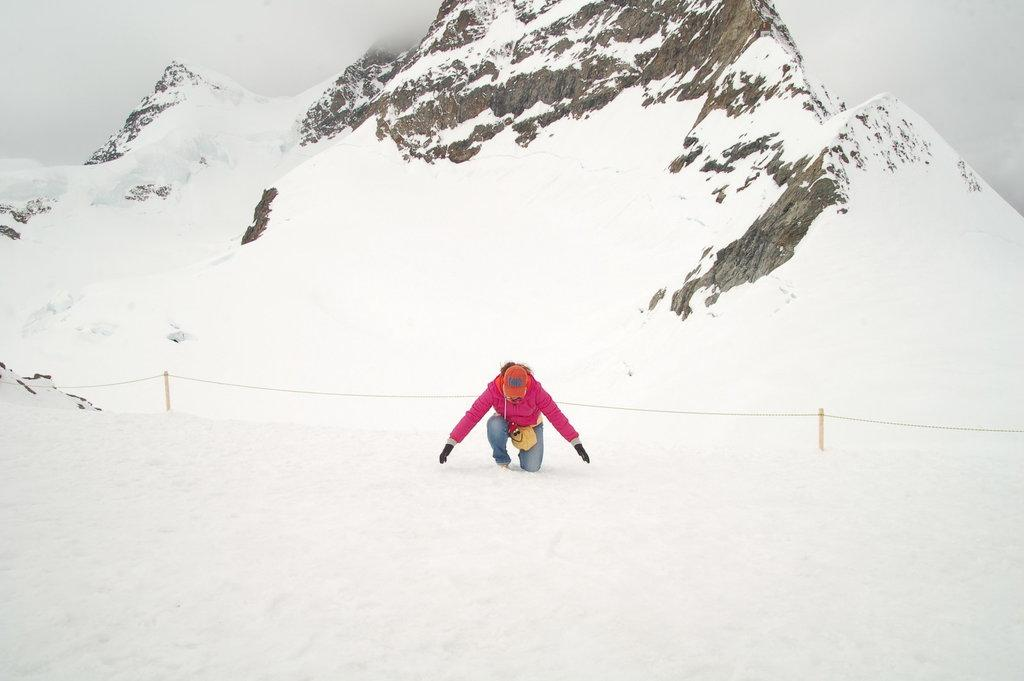What is the main subject in the foreground of the image? There is a person in the foreground of the image. What is the person doing in the image? The person is kneeling down on one knee on the snow. What can be seen in the background of the image? There is a railing and a mountain in the background of the image. What is visible above the mountain in the image? The sky is visible in the background of the image. What type of print can be seen on the lamp in the image? There is no lamp present in the image, so it is not possible to determine the type of print on it. 